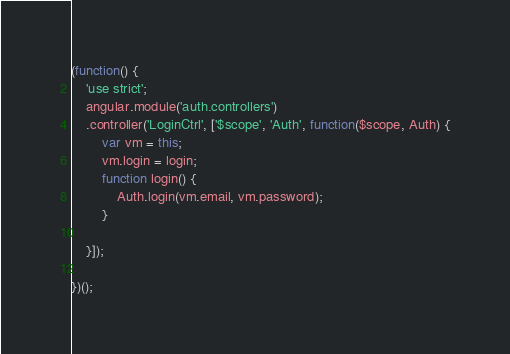<code> <loc_0><loc_0><loc_500><loc_500><_JavaScript_>(function() {
	'use strict';
	angular.module('auth.controllers')
	.controller('LoginCtrl', ['$scope', 'Auth', function($scope, Auth) {
		var vm = this;
		vm.login = login;
		function login() {
			Auth.login(vm.email, vm.password);
		}

	}]);

})();</code> 